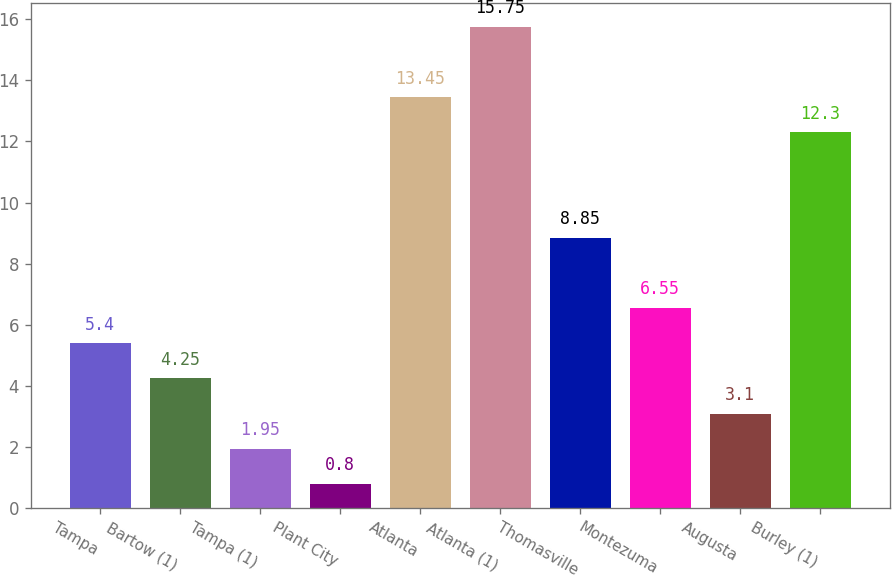Convert chart to OTSL. <chart><loc_0><loc_0><loc_500><loc_500><bar_chart><fcel>Tampa<fcel>Bartow (1)<fcel>Tampa (1)<fcel>Plant City<fcel>Atlanta<fcel>Atlanta (1)<fcel>Thomasville<fcel>Montezuma<fcel>Augusta<fcel>Burley (1)<nl><fcel>5.4<fcel>4.25<fcel>1.95<fcel>0.8<fcel>13.45<fcel>15.75<fcel>8.85<fcel>6.55<fcel>3.1<fcel>12.3<nl></chart> 